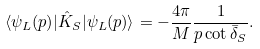Convert formula to latex. <formula><loc_0><loc_0><loc_500><loc_500>\langle \psi _ { L } ( p ) | \hat { K } _ { S } | \psi _ { L } ( p ) \rangle = - \frac { 4 \pi } { M } \frac { 1 } { p \cot \bar { \delta } _ { S } } .</formula> 